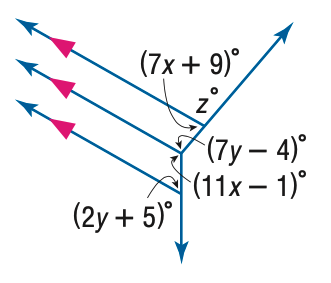Question: Find z in the figure.
Choices:
A. 27
B. 73
C. 89
D. 153
Answer with the letter. Answer: B Question: Find y in the figure.
Choices:
A. 11
B. 12
C. 13
D. 14
Answer with the letter. Answer: A 